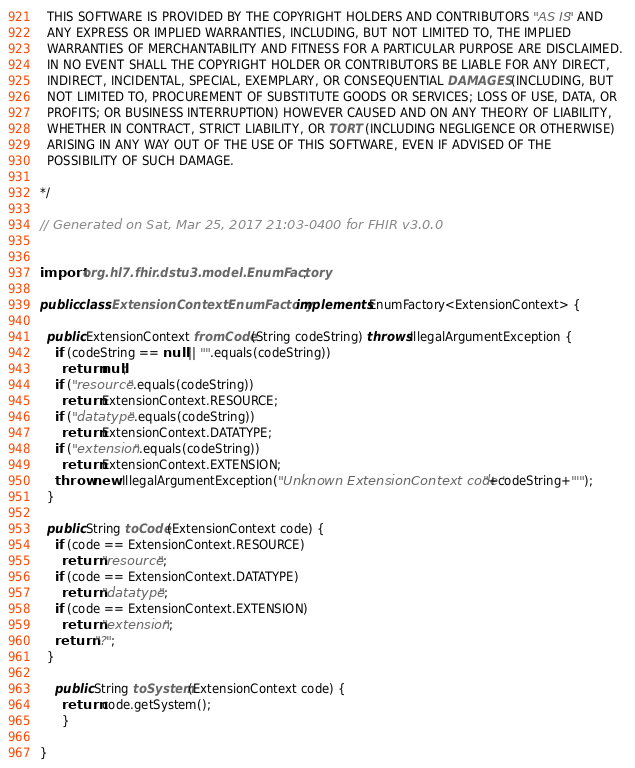<code> <loc_0><loc_0><loc_500><loc_500><_Java_>  THIS SOFTWARE IS PROVIDED BY THE COPYRIGHT HOLDERS AND CONTRIBUTORS "AS IS" AND 
  ANY EXPRESS OR IMPLIED WARRANTIES, INCLUDING, BUT NOT LIMITED TO, THE IMPLIED 
  WARRANTIES OF MERCHANTABILITY AND FITNESS FOR A PARTICULAR PURPOSE ARE DISCLAIMED. 
  IN NO EVENT SHALL THE COPYRIGHT HOLDER OR CONTRIBUTORS BE LIABLE FOR ANY DIRECT, 
  INDIRECT, INCIDENTAL, SPECIAL, EXEMPLARY, OR CONSEQUENTIAL DAMAGES (INCLUDING, BUT 
  NOT LIMITED TO, PROCUREMENT OF SUBSTITUTE GOODS OR SERVICES; LOSS OF USE, DATA, OR 
  PROFITS; OR BUSINESS INTERRUPTION) HOWEVER CAUSED AND ON ANY THEORY OF LIABILITY, 
  WHETHER IN CONTRACT, STRICT LIABILITY, OR TORT (INCLUDING NEGLIGENCE OR OTHERWISE) 
  ARISING IN ANY WAY OUT OF THE USE OF THIS SOFTWARE, EVEN IF ADVISED OF THE 
  POSSIBILITY OF SUCH DAMAGE.
  
*/

// Generated on Sat, Mar 25, 2017 21:03-0400 for FHIR v3.0.0


import org.hl7.fhir.dstu3.model.EnumFactory;

public class ExtensionContextEnumFactory implements EnumFactory<ExtensionContext> {

  public ExtensionContext fromCode(String codeString) throws IllegalArgumentException {
    if (codeString == null || "".equals(codeString))
      return null;
    if ("resource".equals(codeString))
      return ExtensionContext.RESOURCE;
    if ("datatype".equals(codeString))
      return ExtensionContext.DATATYPE;
    if ("extension".equals(codeString))
      return ExtensionContext.EXTENSION;
    throw new IllegalArgumentException("Unknown ExtensionContext code '"+codeString+"'");
  }

  public String toCode(ExtensionContext code) {
    if (code == ExtensionContext.RESOURCE)
      return "resource";
    if (code == ExtensionContext.DATATYPE)
      return "datatype";
    if (code == ExtensionContext.EXTENSION)
      return "extension";
    return "?";
  }

    public String toSystem(ExtensionContext code) {
      return code.getSystem();
      }

}

</code> 